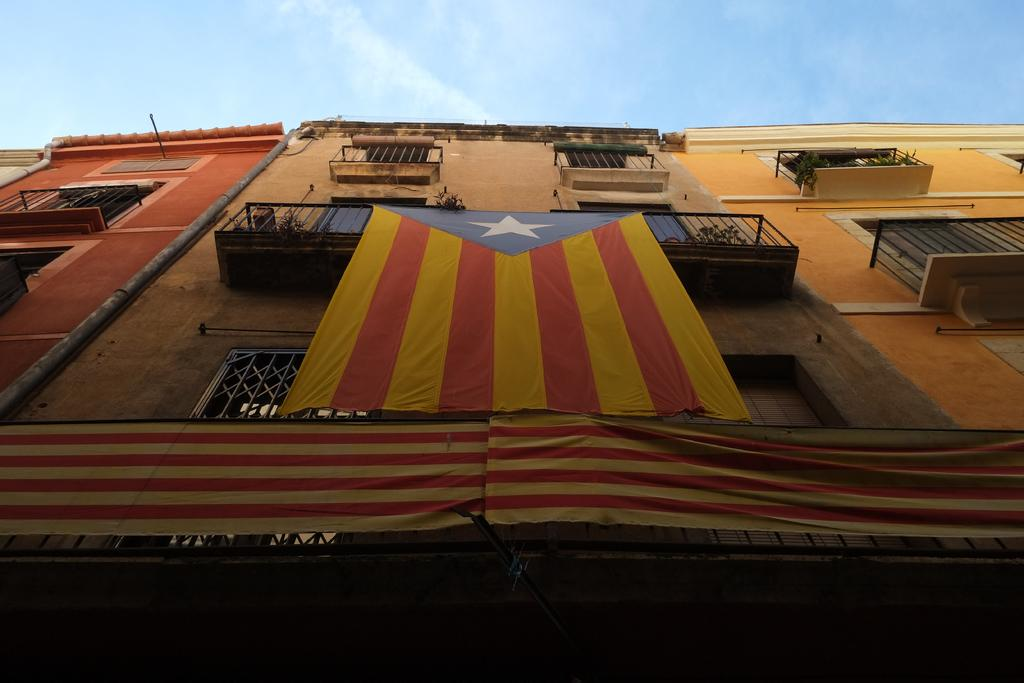What type of structures are present in the image? There are buildings in the image. Can you describe any specific features of the buildings? A pipe is attached to one of the buildings, and flags are attached to the buildings. What can be seen in the background of the image? The sky is visible in the background of the image. What type of circle is being represented by the flags in the image? There is no circle being represented by the flags in the image. The flags are attached to the buildings, but they do not form a circle or represent any specific shape. 